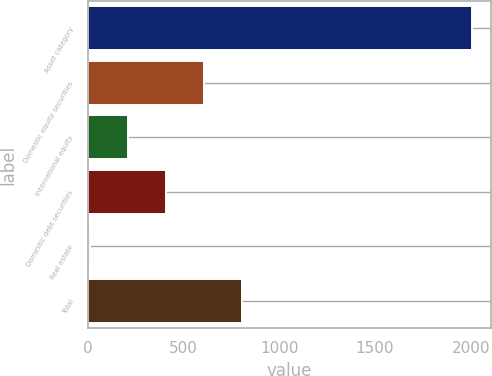Convert chart to OTSL. <chart><loc_0><loc_0><loc_500><loc_500><bar_chart><fcel>Asset category<fcel>Domestic equity securities<fcel>International equity<fcel>Domestic debt securities<fcel>Real estate<fcel>Total<nl><fcel>2006<fcel>608.1<fcel>208.7<fcel>408.4<fcel>9<fcel>807.8<nl></chart> 